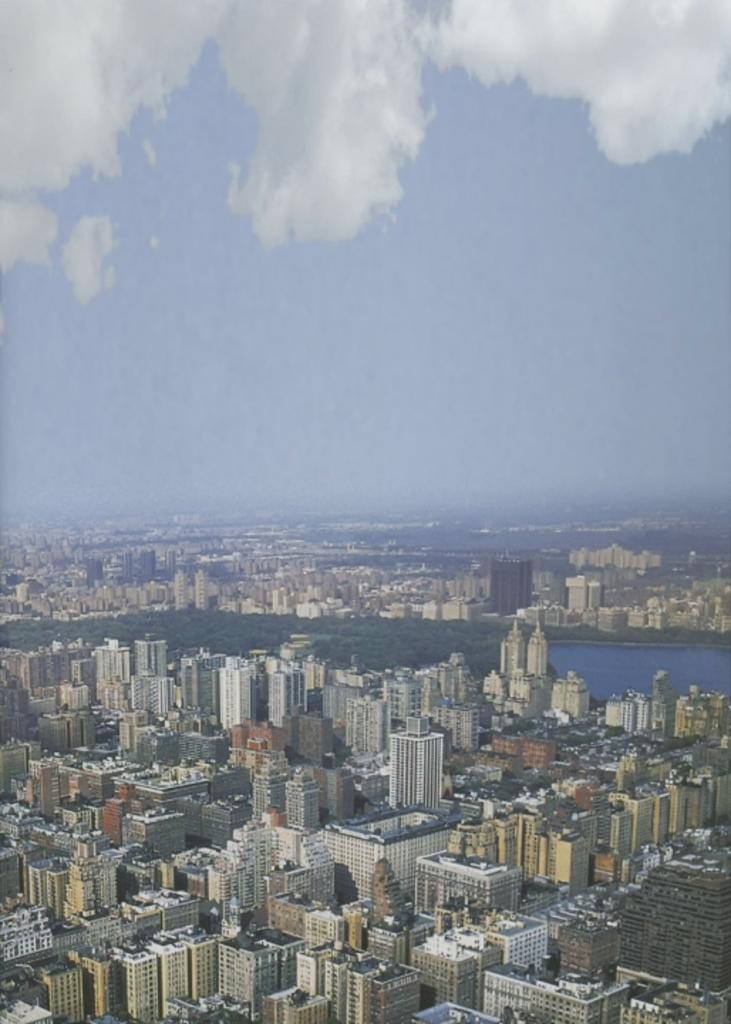What type of location is depicted in the image? The image depicts a city. What structures can be seen at the bottom of the image? Skyscrapers and buildings are present at the bottom of the image. What type of structures are also present at the bottom of the image? Sheds are present at the bottom of the image. What geographical feature is located in the center of the image? There is a lake in the center of the image. What is visible at the top of the image? The sky is visible at the top of the image. What can be seen in the sky? Clouds are present in the sky. How many dolls can be seen playing with the father in the image? There are no dolls or fathers present in the image; it depicts a city with various structures and a lake. 